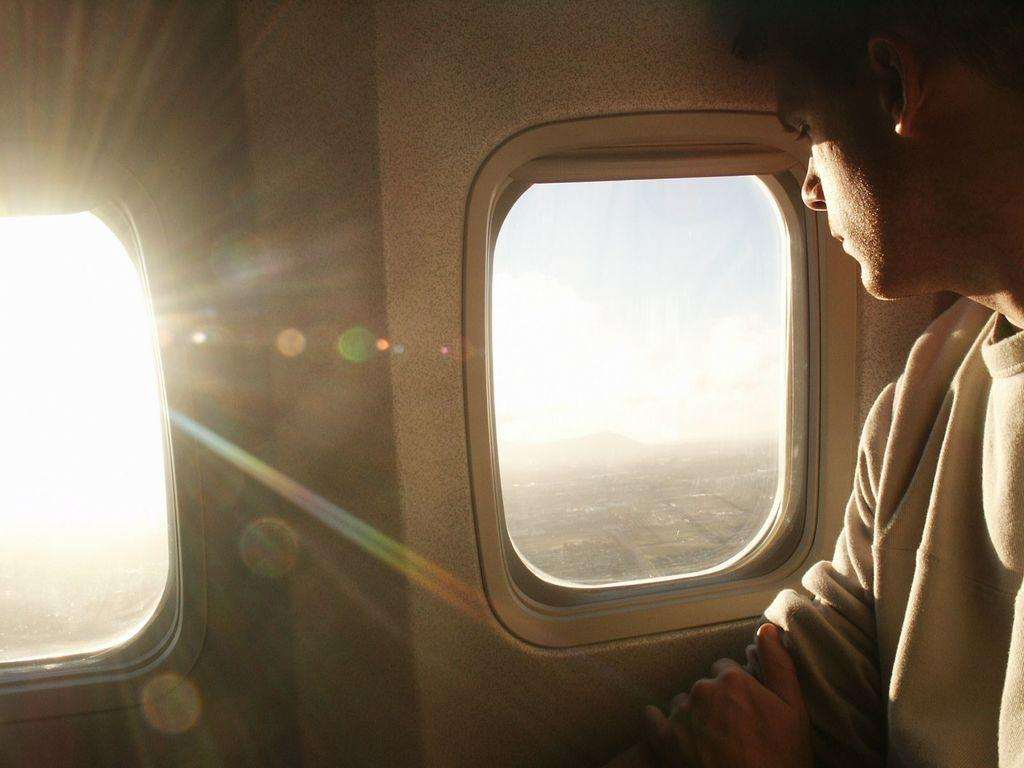Where is the man located in the image? The man is inside an airplane in the image. What type of windows does the airplane have? The airplane has glass windows. What can be seen through the windows of the airplane? The sky is visible through the windows. What flavor of zebra can be tasted in the image? There is no zebra present in the image, and therefore no flavor can be tasted. 